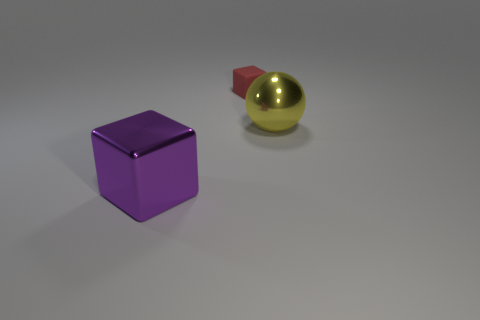Is there any other thing that is the same size as the red rubber object?
Offer a terse response. No. The other metal object that is the same shape as the tiny red thing is what size?
Your response must be concise. Large. Do the purple metallic block and the red cube have the same size?
Keep it short and to the point. No. There is a red matte cube to the left of the big thing that is to the right of the large shiny cube; what is its size?
Offer a terse response. Small. How many purple things have the same material as the red block?
Provide a short and direct response. 0. Is there a small gray object?
Offer a very short reply. No. What size is the block that is behind the purple cube?
Provide a short and direct response. Small. How many large blocks are the same color as the big ball?
Make the answer very short. 0. What number of cylinders are either purple metal objects or tiny red objects?
Ensure brevity in your answer.  0. There is a thing that is both in front of the small rubber cube and behind the purple thing; what is its shape?
Your response must be concise. Sphere. 